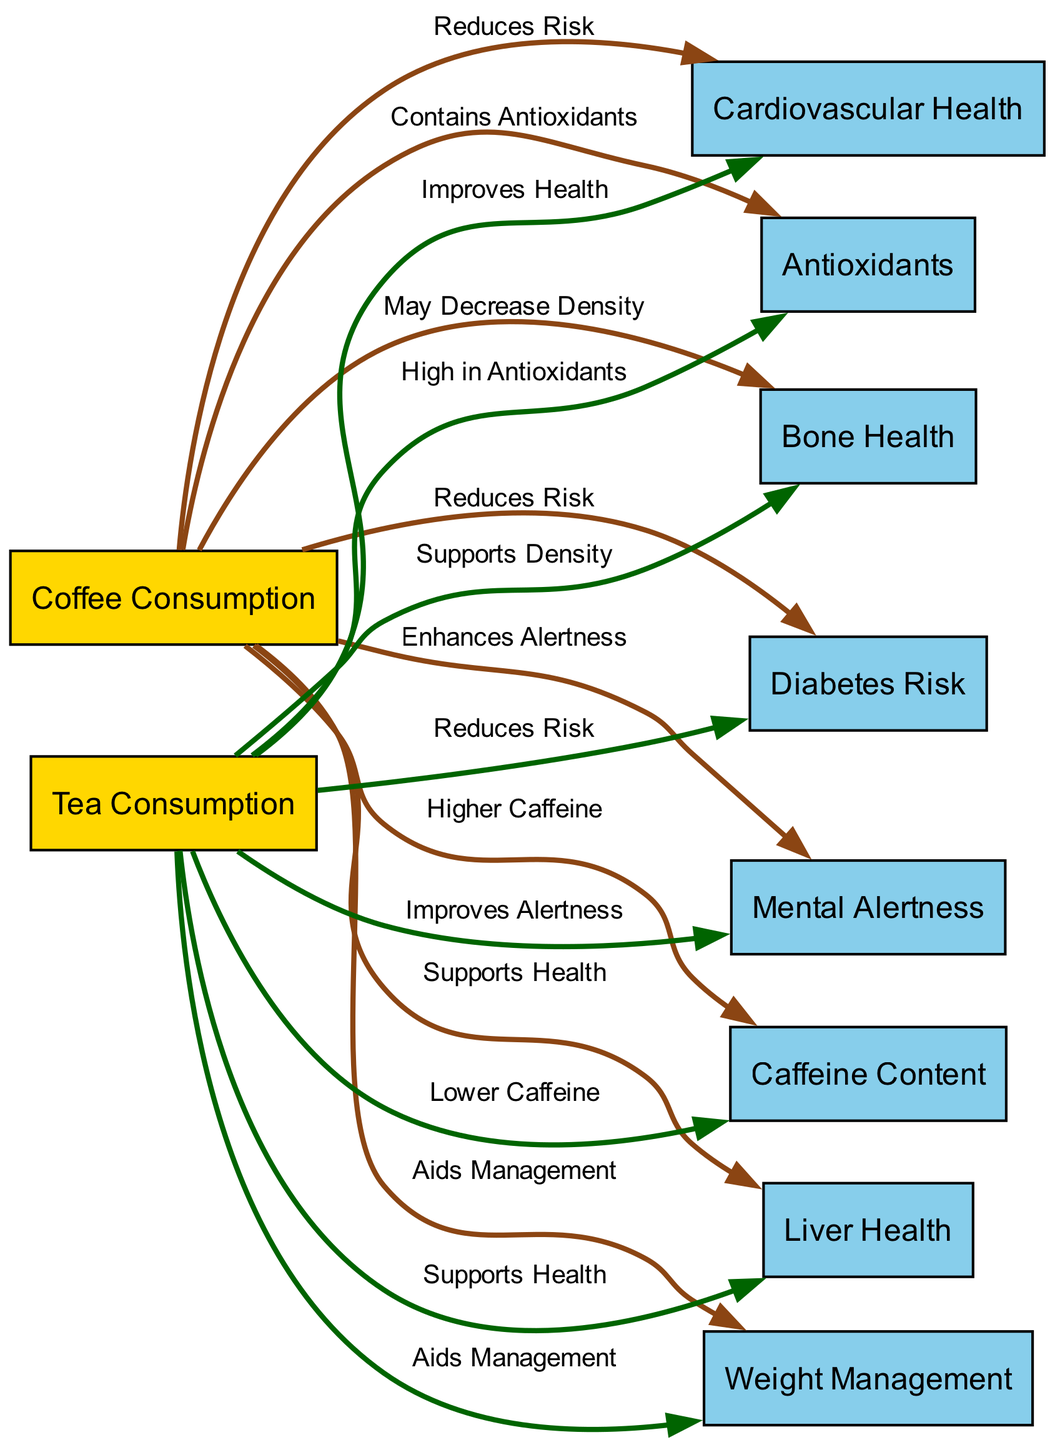What is the relationship between coffee consumption and cardiovascular health? The diagram shows an edge pointing from "coffee" to "cardiovascular_health" indicating that coffee "Reduces Risk." This means there is a direct positive relationship where coffee consumption is associated with a decreased risk of cardiovascular issues.
Answer: Reduces Risk How many nodes are represented in the diagram? By counting the number of nodes present in the diagram, we find a total of 10 distinct nodes including both coffee and tea consumption, along with the health outcomes related to them.
Answer: 10 Which beverage has higher caffeine content? The diagram clearly states an edge from "coffee" to "caffeine_content" with the label "Higher Caffeine," which directly indicates that coffee has more caffeine compared to tea.
Answer: Coffee What does tea improve regarding mental alertness? The diagram indicates an edge from "tea" to "mental_alertness" labeled "Improves Alertness," showing that tea has a beneficial effect on mental alertness as depicted in the relationships.
Answer: Improves Alertness What is the combined effect of coffee and tea on diabetes risk? Both coffee and tea have edges leading to "diabetes_risk," with labels stating "Reduces Risk" for both beverages. This indicates that both drinks have a similar positive effect in decreasing diabetes risk.
Answer: Reduces Risk How does tea contribute to bone health? The diagram shows an edge pointing from "tea" to "bone_health" labeled "Supports Density," indicating that tea has a positive contribution to bone health by supporting bone density.
Answer: Supports Density In terms of antioxidants, how do coffee and tea compare? The diagram includes an edge from "coffee" to "antioxidants" labeled "Contains Antioxidants" and another edge from "tea" to "antioxidants" with the label "High in Antioxidants," illustrating that both beverages are beneficial in different ways regarding antioxidants.
Answer: High in Antioxidants Which beverage aids in weight management? There are edges leading from both "coffee" and "tea" to "weight_management," with the label "Aids Management," indicating that both beverages have a role in weight management.
Answer: Aids Management What is the potential negative effect of coffee on bone health? The diagram includes an edge from "coffee" to "bone_health" labeled "May Decrease Density," suggesting that coffee potentially has a negative effect on bone density.
Answer: May Decrease Density 